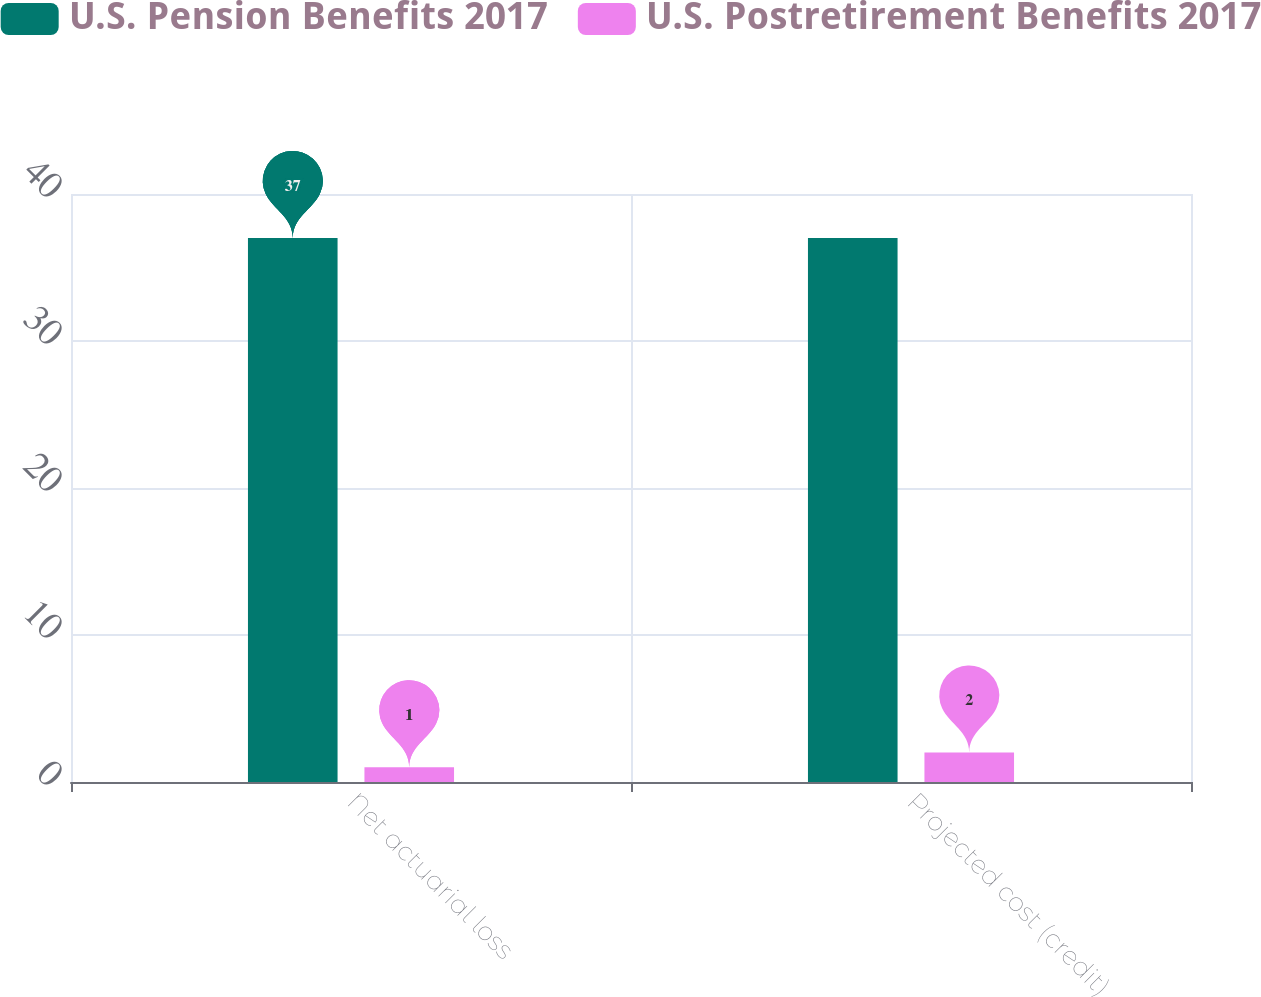Convert chart to OTSL. <chart><loc_0><loc_0><loc_500><loc_500><stacked_bar_chart><ecel><fcel>Net actuarial loss<fcel>Projected cost (credit)<nl><fcel>U.S. Pension Benefits 2017<fcel>37<fcel>37<nl><fcel>U.S. Postretirement Benefits 2017<fcel>1<fcel>2<nl></chart> 